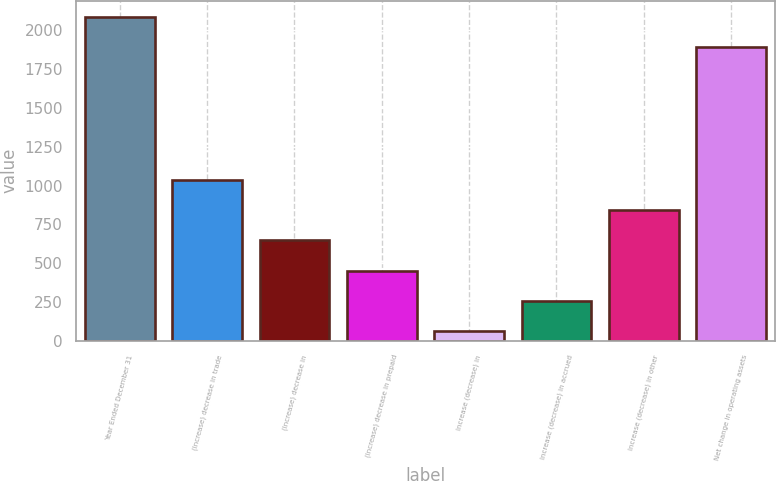<chart> <loc_0><loc_0><loc_500><loc_500><bar_chart><fcel>Year Ended December 31<fcel>(Increase) decrease in trade<fcel>(Increase) decrease in<fcel>(Increase) decrease in prepaid<fcel>Increase (decrease) in<fcel>Increase (decrease) in accrued<fcel>Increase (decrease) in other<fcel>Net change in operating assets<nl><fcel>2087.8<fcel>1037<fcel>647.4<fcel>452.6<fcel>63<fcel>257.8<fcel>842.2<fcel>1893<nl></chart> 